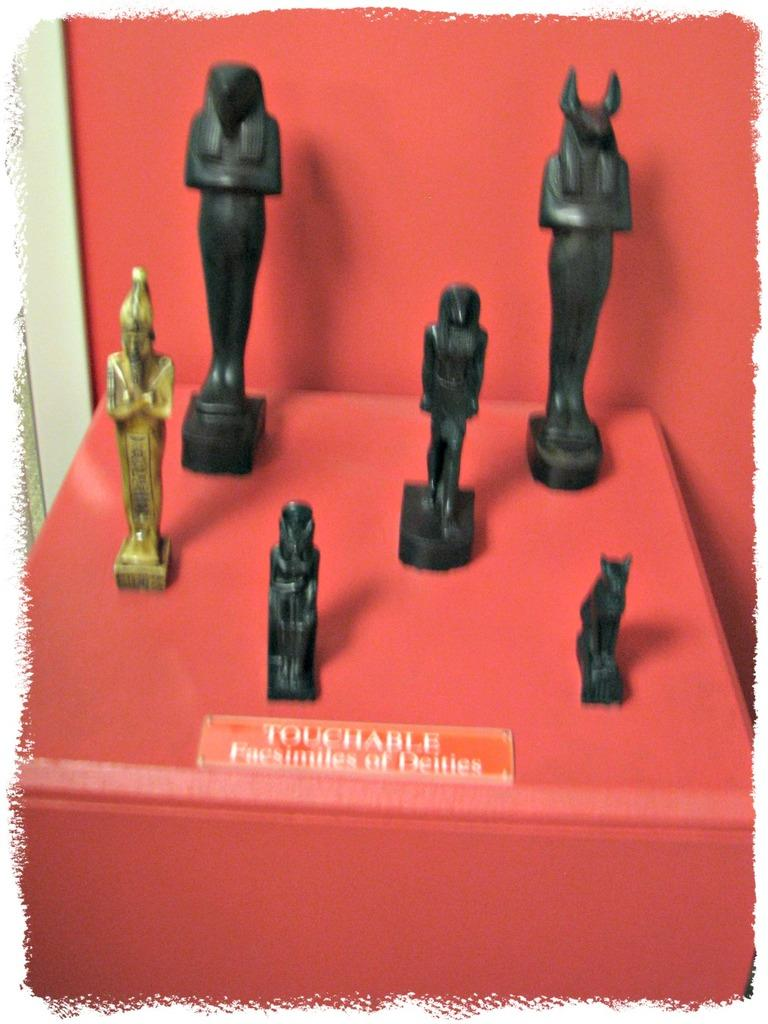What type of objects can be seen in the image? There are statues in the image. Is there any text or identification in the image? Yes, there is a name plate in the image. What is the color of the platform on which the statues and name plate are placed? The platform is red. What type of lumber is used to construct the statues in the image? The provided facts do not mention the material used to construct the statues, so we cannot determine if lumber was used. Is there any poison or wound visible in the image? No, there is no mention of poison or wounds in the provided facts, and they are not visible in the image. 